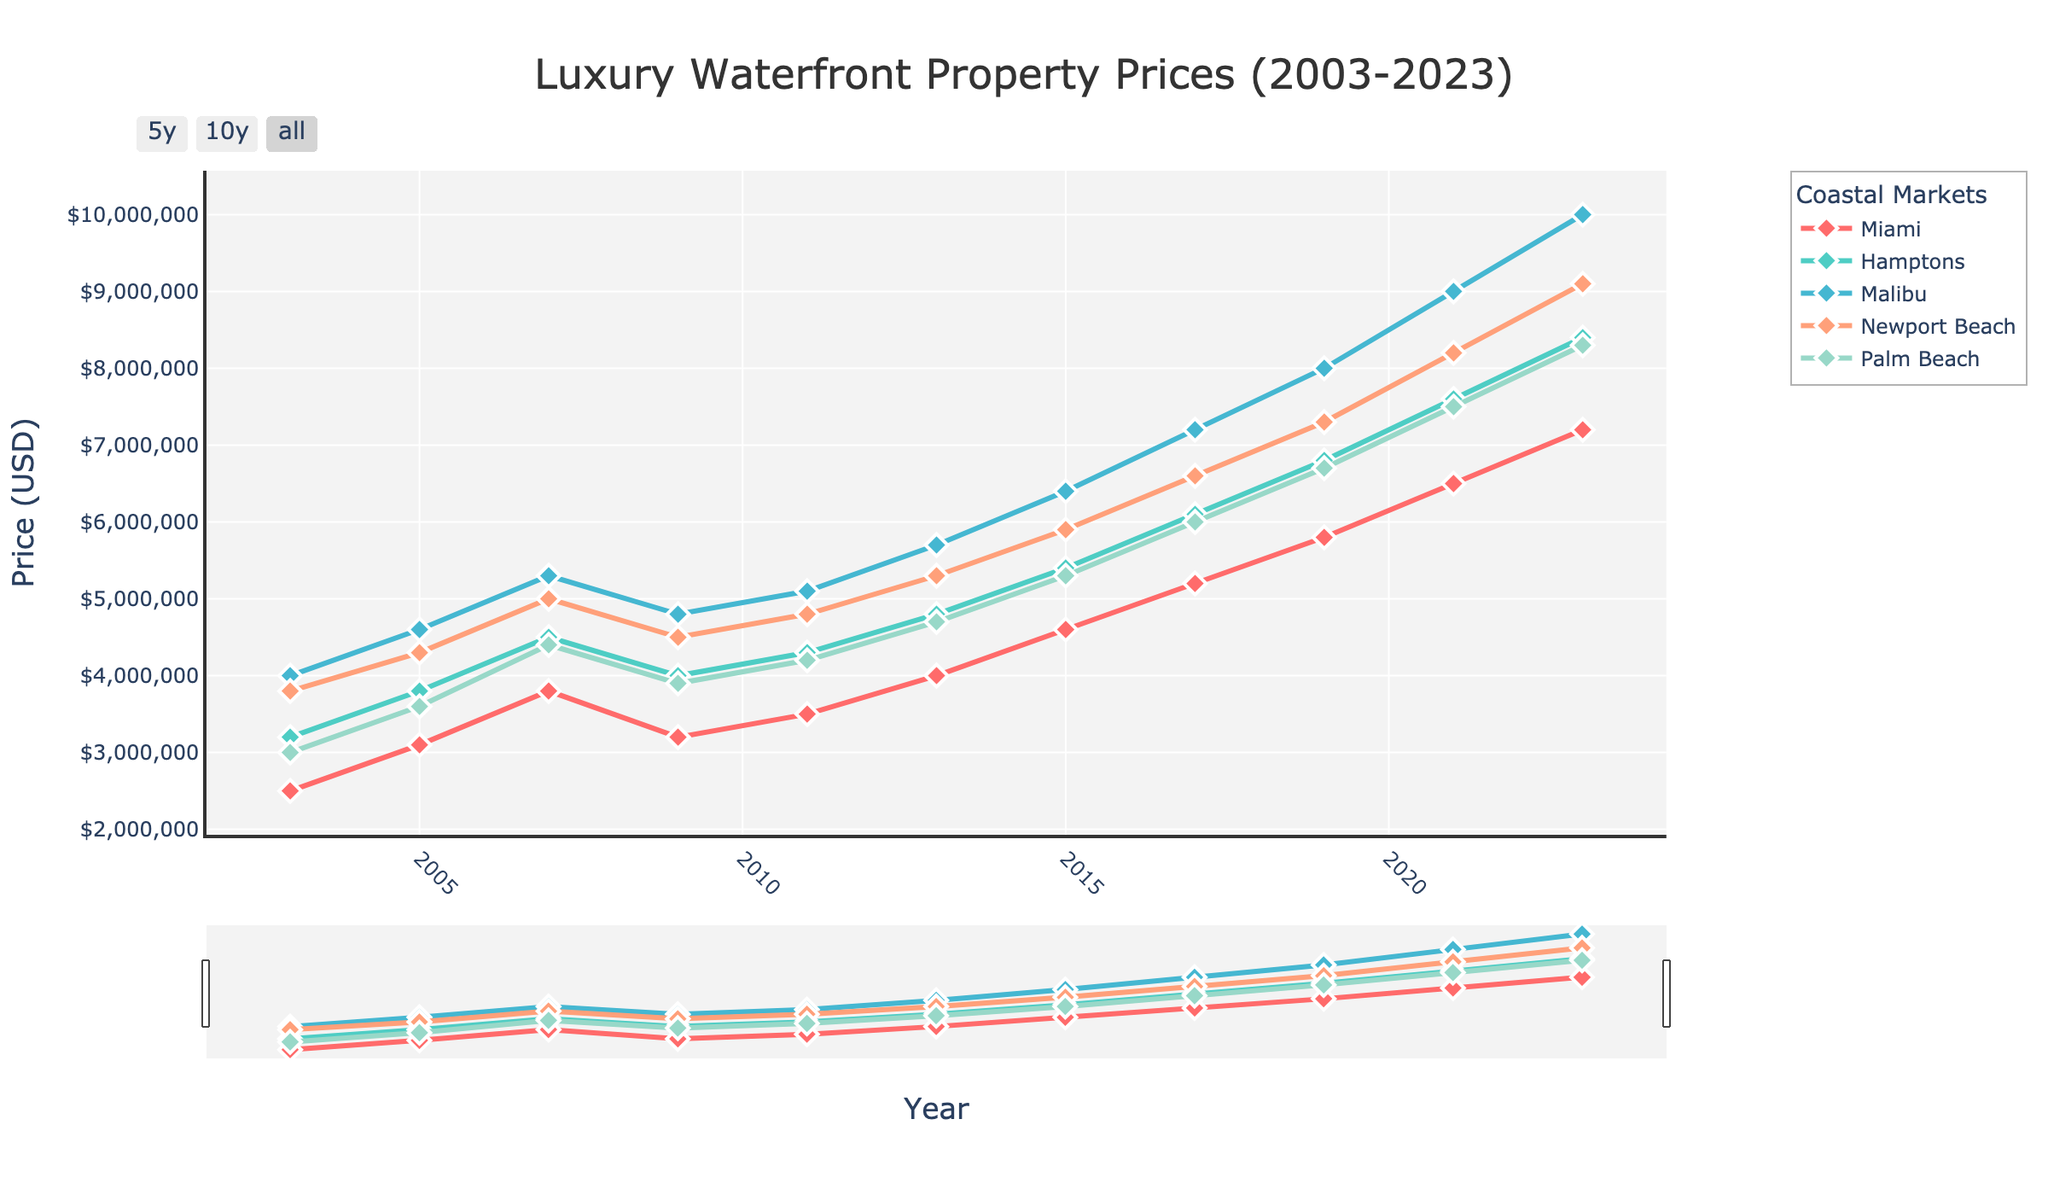what were the average prices of luxury waterfront properties in Miami and Newport Beach in 2015? First, find the prices for Miami and Newport Beach in 2015 from the chart (Miami: 4,600,000; Newport Beach: 5,900,000). Then, calculate the average: (4,600,000 + 5,900,000) / 2 = 5,250,000
Answer: 5,250,000 which coastal market had the highest average price trend in 2023? Look at the data points for 2023 across all markets. Identify the highest price: Miami (7,200,000), Hamptons (8,400,000), Malibu (10,000,000), Newport Beach (9,100,000), Palm Beach (8,300,000). Malibu has the highest value.
Answer: Malibu how much did the average price of luxury waterfront properties in Palm Beach increase from 2003 to 2023? Note the prices for Palm Beach in 2003 (3,000,000) and 2023 (8,300,000). Calculate the difference: 8,300,000 - 3,000,000 = 5,300,000
Answer: 5,300,000 which city experienced the smallest drop in 2009 compared to 2007? First, identify prices in 2007 and 2009: Miami (3,800,000; 3,200,000), Hamptons (4,500,000; 4,000,000), Malibu (5,300,000; 4,800,000), Newport Beach (5,000,000; 4,500,000), Palm Beach (4,400,000; 3,900,000), then calculate the drop: Miami (600,000), Hamptons (500,000), Malibu (500,000), Newport Beach (500,000), Palm Beach (500,000). Newport Beach, Malibu, and Hamptons have equal smallest drops.
Answer: Hamptons, Malibu, Newport Beach what are the visual attributes used for marking the data points in the plot? Observe the data points on the plot, noting their size, shape, color, and any additional characteristics (larger size, diamond shape, varied colors for each market, white border).
Answer: Larger size, diamond shape, varied colors, white border did average property prices in any market remain the same for consecutive periods? Check the trend lines for any flat segments, which indicate unchanged prices. No market shows a flat trend line across consecutive periods.
Answer: No which city showed the consistent upward trend without any drops over the 20-year period? Observe the trend lines over time. Identify if any city consistently rises without drops: Miami, Hamptons, Malibu, Newport Beach, Palm Beach. None of the cities show a consistent upward trend without any drops.
Answer: None what is the average price for Malibu properties over the entire 20-year period? Note Malibu’s prices from the chart: 4,000,000, 4,600,000, 5,300,000, 4,800,000, 5,100,000, 5,700,000, 6,400,000, 7,200,000, 8,000,000, 9,000,000, 10,000,000. Calculate the average: (4,000,000 + 4,600,000 + 5,300,000 + 4,800,000 + 5,100,000 + 5,700,000 + 6,400,000 + 7,200,000 + 8,000,000 + 9,000,000 + 10,000,000) / 11 = 6,672,727
Answer: 6,672,727 